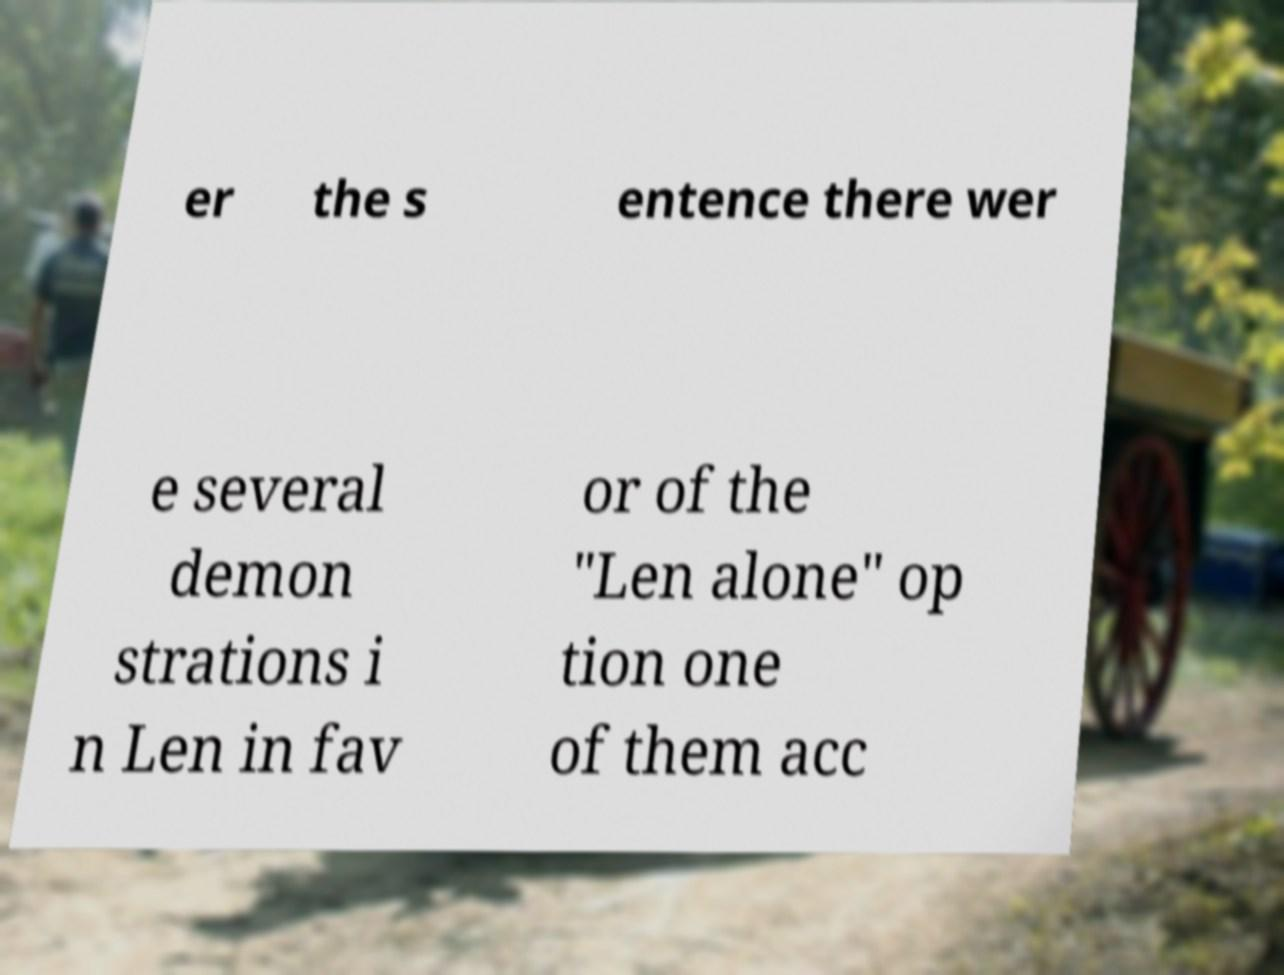Can you accurately transcribe the text from the provided image for me? er the s entence there wer e several demon strations i n Len in fav or of the "Len alone" op tion one of them acc 